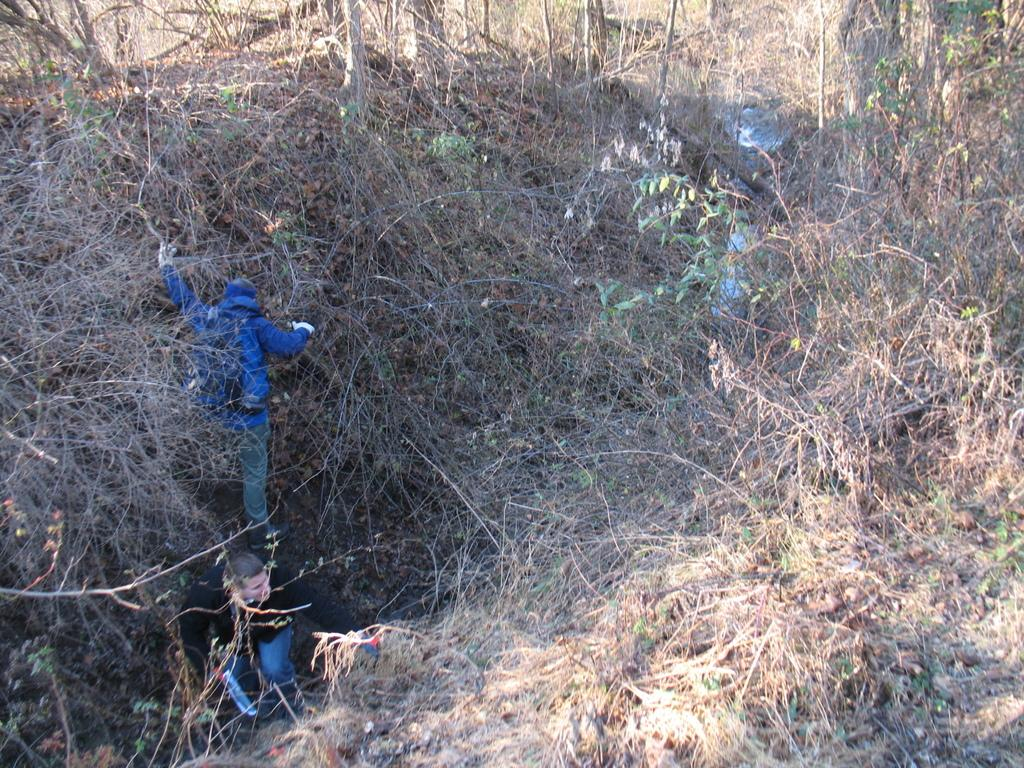How many people are in the image? There are two members in the image. Where are the members located in the image? The members are on the left side of the image. What type of vegetation can be seen in the image? There are dried plants and trees in the image. What is the clothing color of one of the men in the image? One of the men is wearing a blue color hoodie. Can you tell me how many goldfish are swimming in the image? There are no goldfish present in the image. What is the condition of the toe of the man wearing the blue hoodie? There is no information about the toe of the man wearing the blue hoodie in the image. 